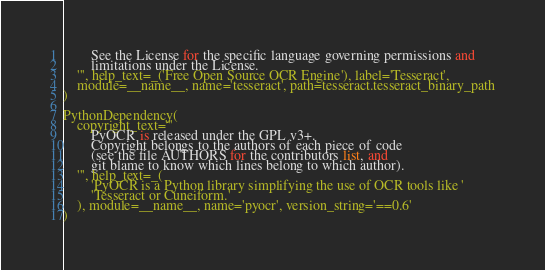<code> <loc_0><loc_0><loc_500><loc_500><_Python_>        See the License for the specific language governing permissions and
        limitations under the License.
    ''', help_text=_('Free Open Source OCR Engine'), label='Tesseract',
    module=__name__, name='tesseract', path=tesseract.tesseract_binary_path
)

PythonDependency(
    copyright_text='''
        PyOCR is released under the GPL v3+.
        Copyright belongs to the authors of each piece of code
        (see the file AUTHORS for the contributors list, and
        git blame to know which lines belong to which author).
    ''', help_text=_(
        'PyOCR is a Python library simplifying the use of OCR tools like '
        'Tesseract or Cuneiform.'
    ), module=__name__, name='pyocr', version_string='==0.6'
)
</code> 